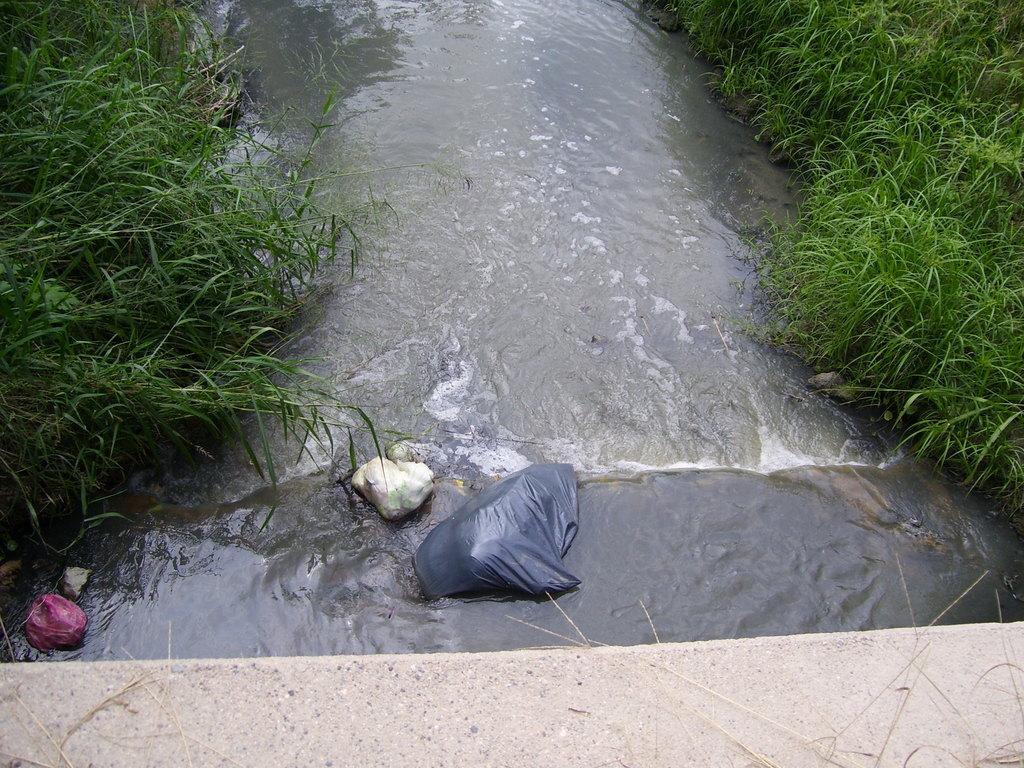Can you describe this image briefly? In this picture we can see some grass on the wall. There are a few colorful covers visible in the water. We can see some green grass on the right and left side of the image. 